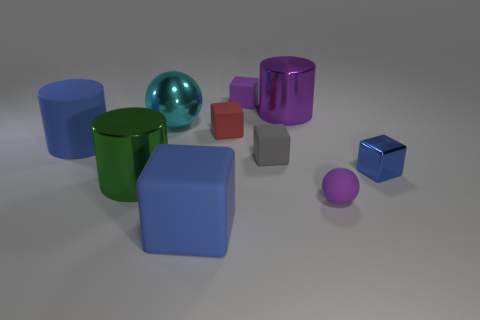Subtract all gray cubes. How many cubes are left? 4 Subtract all big blocks. How many blocks are left? 4 Subtract all brown cubes. Subtract all brown spheres. How many cubes are left? 5 Subtract all spheres. How many objects are left? 8 Subtract all big green objects. Subtract all purple metallic cylinders. How many objects are left? 8 Add 2 small rubber blocks. How many small rubber blocks are left? 5 Add 2 tiny blue shiny blocks. How many tiny blue shiny blocks exist? 3 Subtract 0 red spheres. How many objects are left? 10 